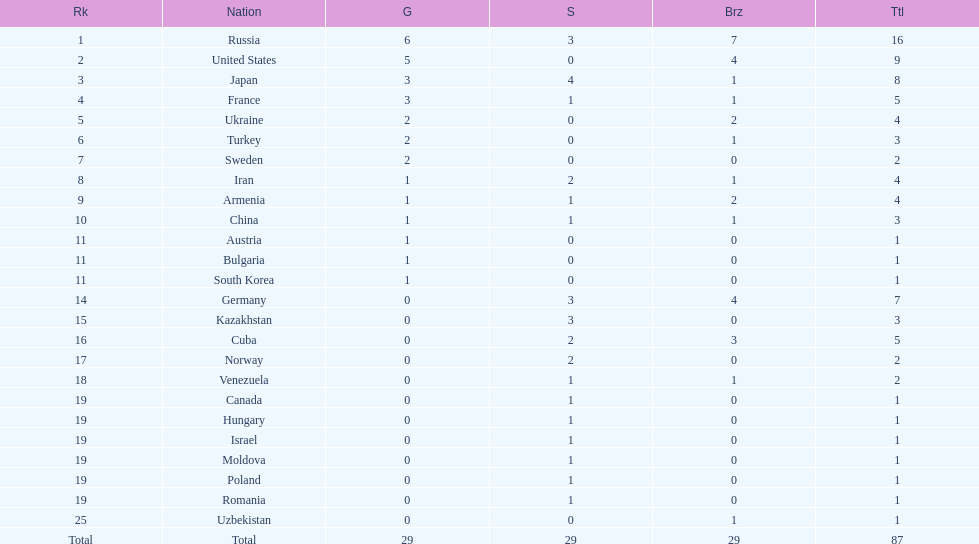How many combined gold medals did japan and france win? 6. 